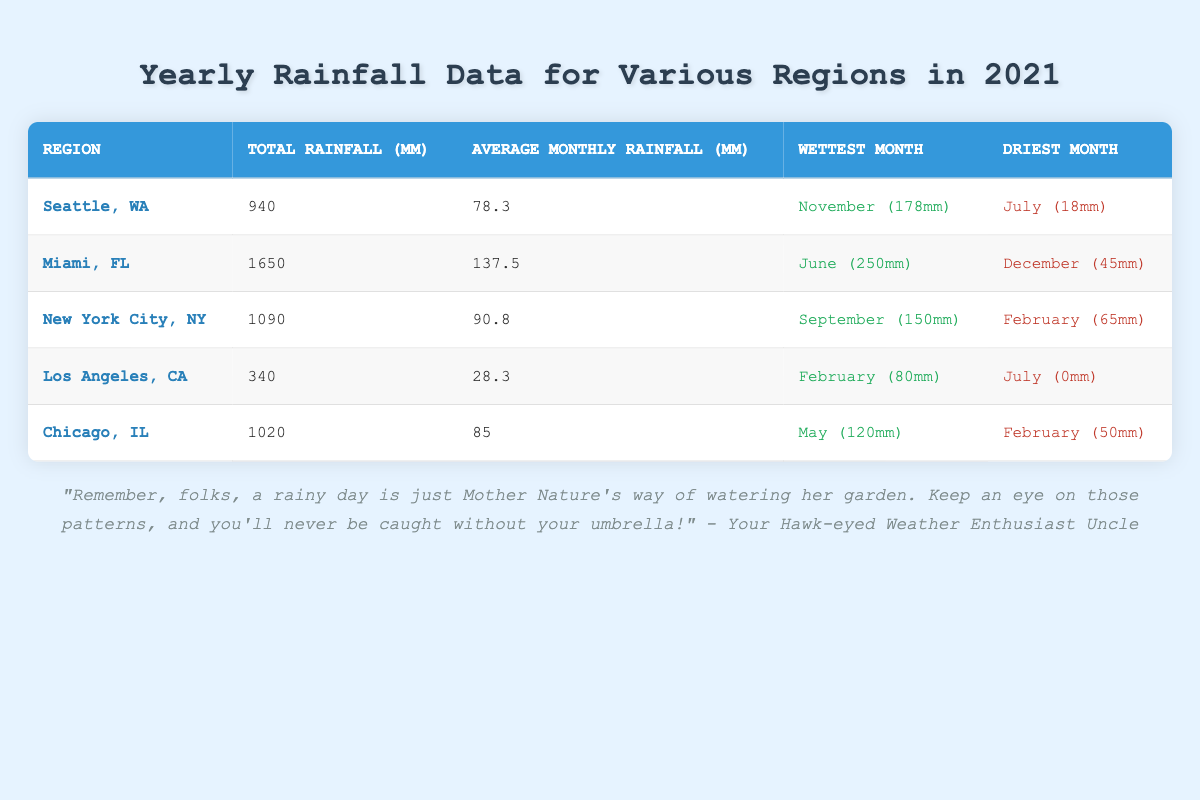What's the total rainfall in Miami, FL? The table shows that the total rainfall in Miami, FL is 1650 mm, which is specified in the Total Rainfall column for that region.
Answer: 1650 mm Which city had the driest month in July? In the table, Los Angeles, CA has its driest month listed as July with 0 mm of rainfall, making it the only region with July designated as the driest month.
Answer: Los Angeles, CA What is the average monthly rainfall for Seattle, WA? The Average Monthly Rainfall column indicates that Seattle, WA has an average monthly rainfall of 78.3 mm for the year 2021.
Answer: 78.3 mm How much more rainfall did Miami, FL receive than Los Angeles, CA in total for 2021? Miami's total rainfall is 1650 mm and Los Angeles's total rainfall is 340 mm. To find the difference, subtract 340 from 1650, resulting in 1310 mm more for Miami.
Answer: 1310 mm Does New York City, NY have a wettest month in which at least 100 mm of rain fell? The wettest month for New York City, NY is September, with a recorded rainfall of 150 mm, which is greater than 100 mm. Thus, the statement is true.
Answer: Yes Which region had the highest average monthly rainfall? By comparing all average monthly rainfall values, Miami, FL has the highest at 137.5 mm, while the lowest is Los Angeles, CA at 28.3 mm. Therefore, Miami has the highest average.
Answer: Miami, FL What is the total rainfall for Chicago, IL and New York City, NY combined? Chicago, IL has a total rainfall of 1020 mm, and New York City, NY has 1090 mm. Adding these together, 1020 + 1090 equals 2110 mm in total.
Answer: 2110 mm Was the driest month in Chicago, IL wetter than the driest month in Los Angeles, CA? Chicago has February as its driest month with 50 mm and Los Angeles has July as the driest with 0 mm. Since 50 mm is greater than 0 mm, it confirms that Chicago's driest month was wetter.
Answer: Yes What is the difference in total rainfall between Seattle, WA and Chicago, IL? Seattle has a total rainfall of 940 mm and Chicago has 1020 mm. The difference is calculated by subtracting 940 from 1020, which equals 80 mm.
Answer: 80 mm 